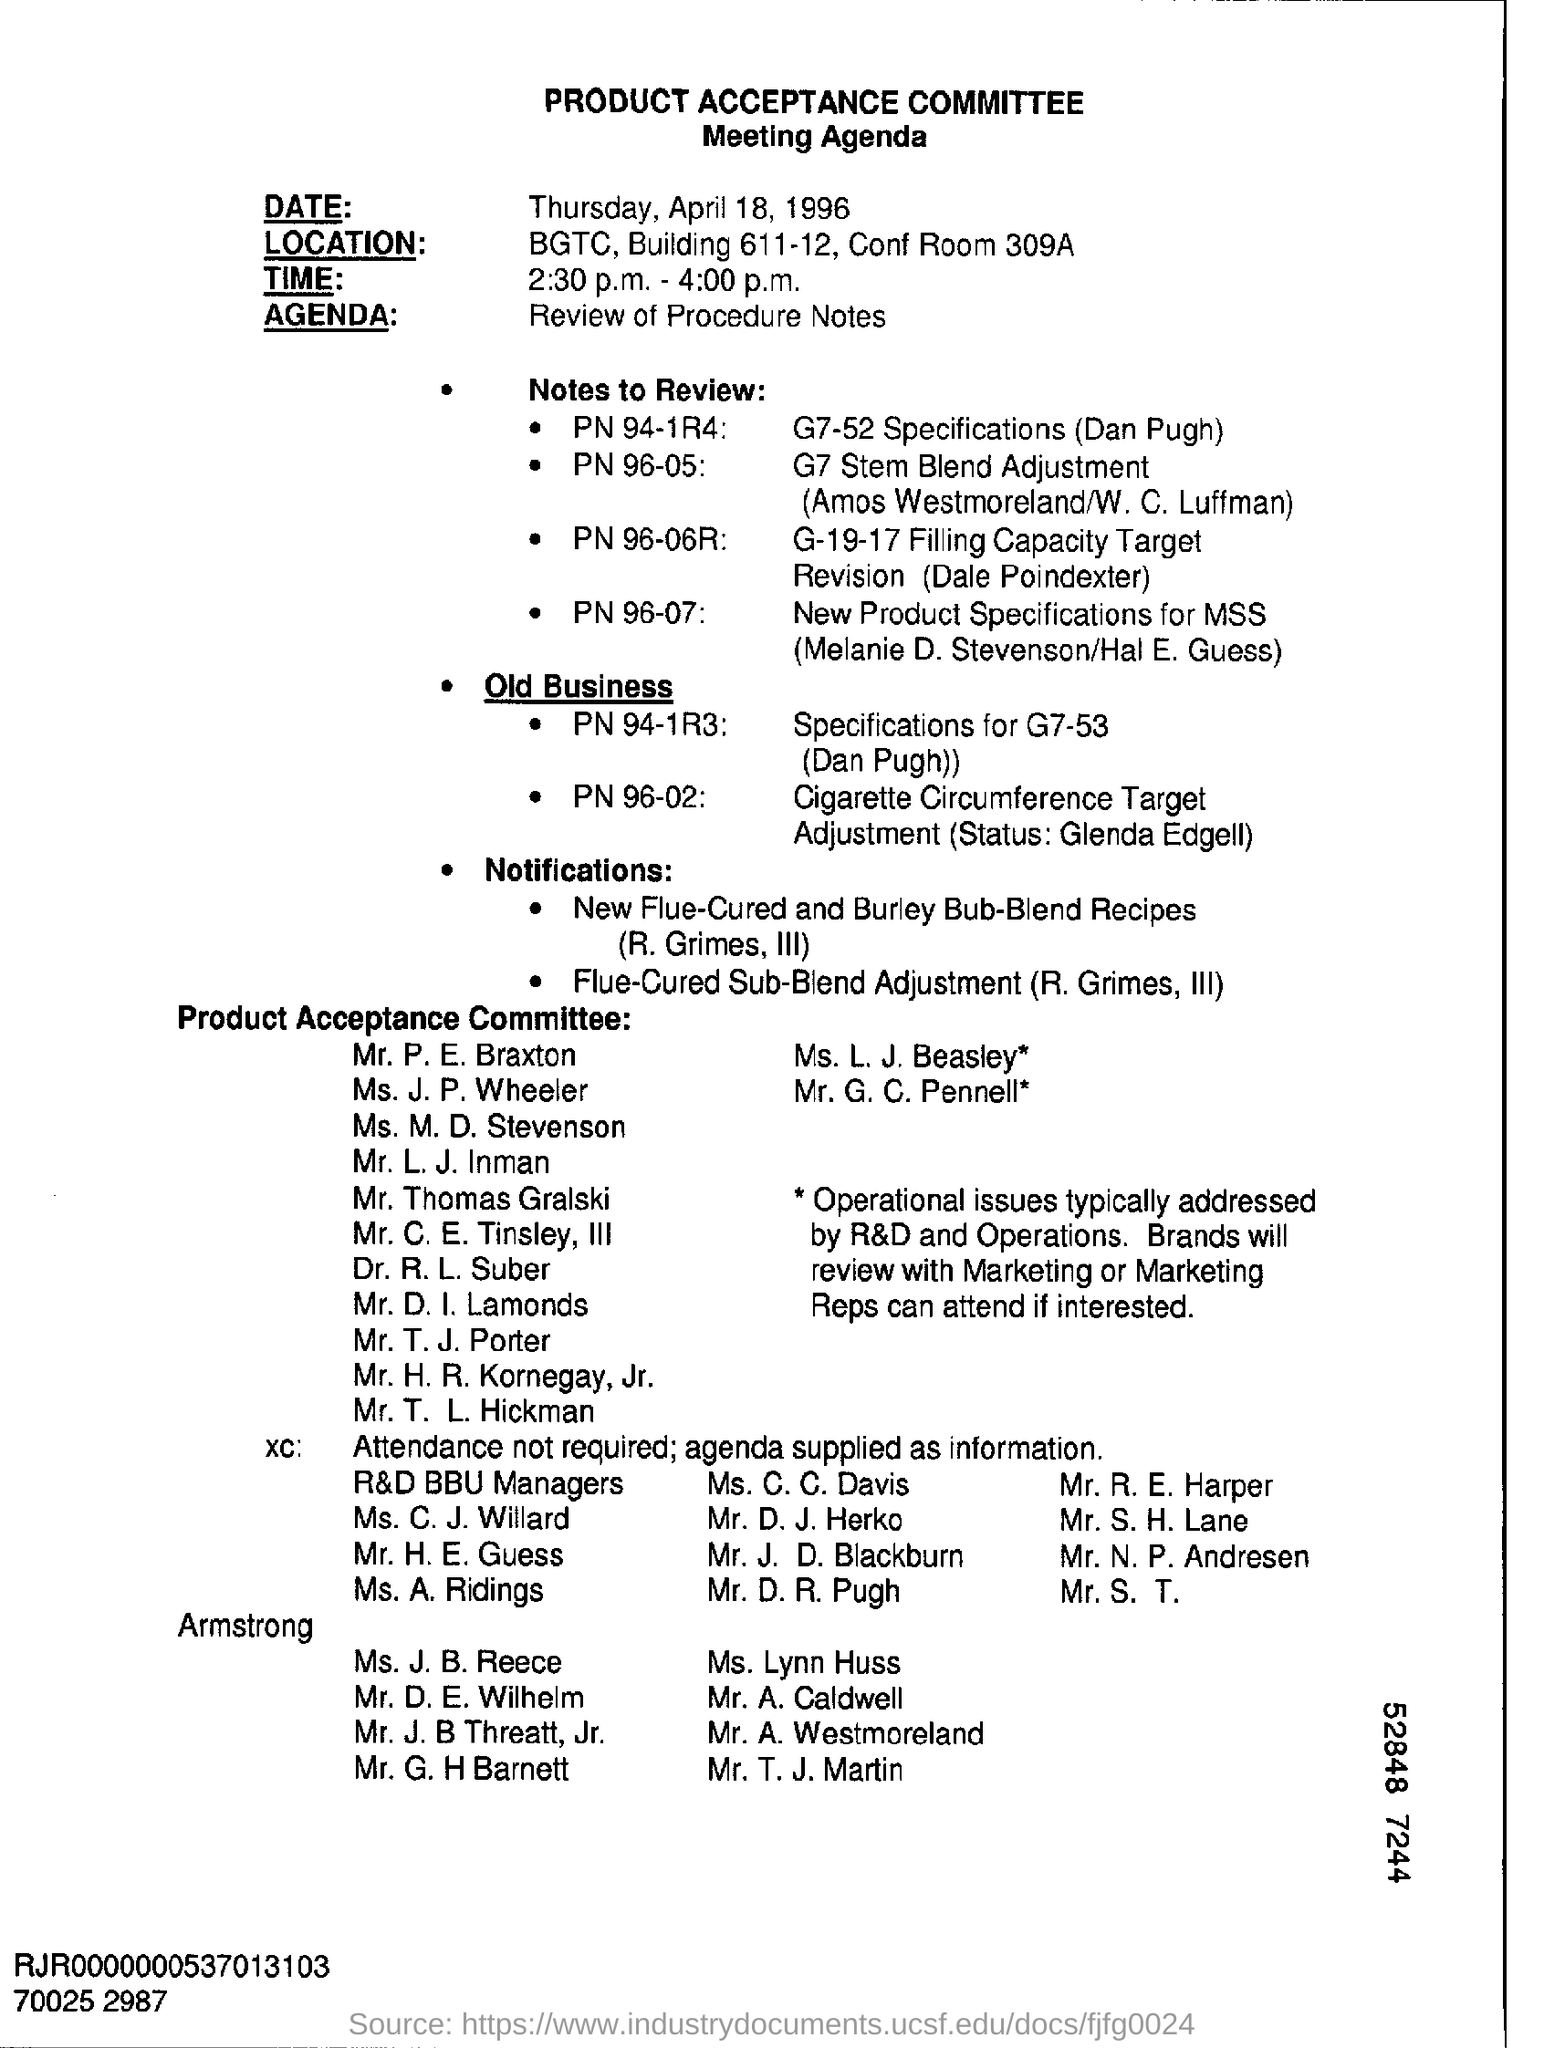What is the Committee Name ?
Offer a terse response. PRODUCT ACCEPTANCE COMMITTEE. What date is the Product Acceptance Committee Meeting scheduled?
Your response must be concise. Thursday, April 18, 1996. What time is the Product Acceptance Committee Meeting scheduled?
Give a very brief answer. 2:30 p.m. - 4:00 p.m. What is written in the Agenda Field ?
Provide a short and direct response. Review of Procedure Notes. 